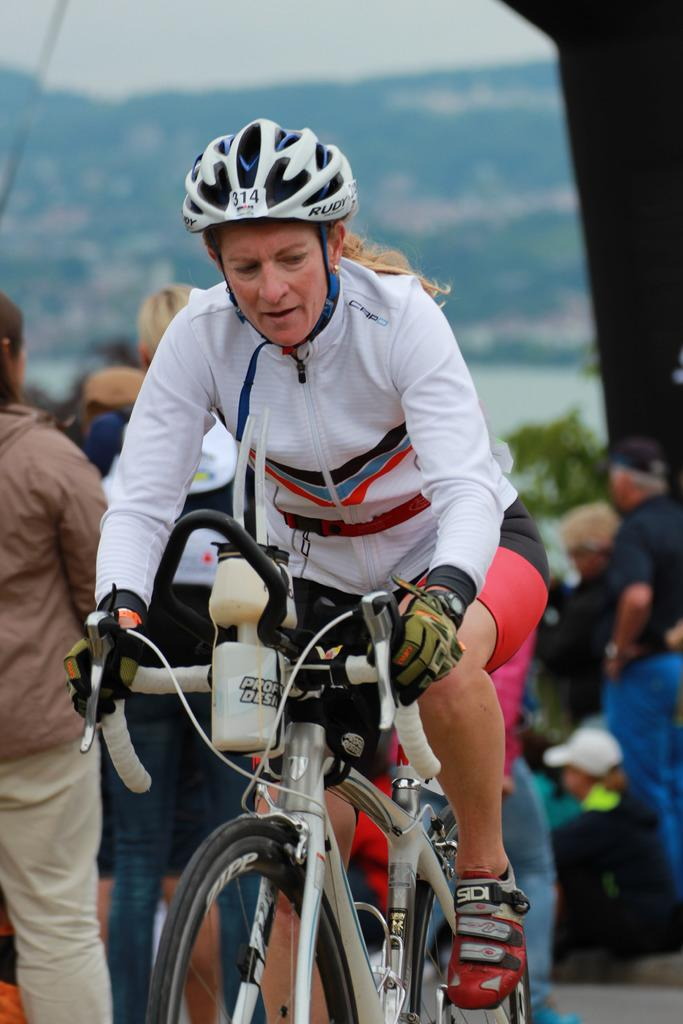Who is the main subject in the image? There is a woman in the image. What is the woman doing in the image? The woman is riding a bicycle. Is the woman wearing any safety gear in the image? Yes, the woman is wearing a helmet in the image. What can be seen in the background of the image? There are people standing in the background of the image. Where are the people located in the image? The people are on the road in the image. What type of orange is the woman holding while riding the bicycle in the image? There is no orange present in the image; the woman is riding a bicycle and wearing a helmet. 